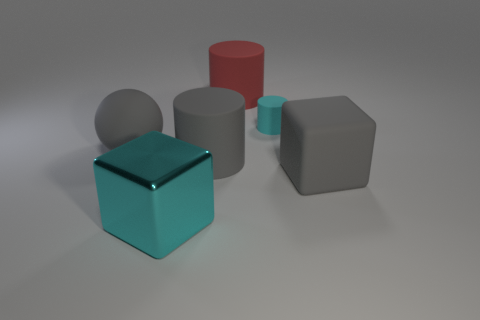Add 1 matte blocks. How many objects exist? 7 Subtract all spheres. How many objects are left? 5 Subtract 0 yellow cubes. How many objects are left? 6 Subtract all big rubber cylinders. Subtract all large gray objects. How many objects are left? 1 Add 3 big cylinders. How many big cylinders are left? 5 Add 1 cyan matte objects. How many cyan matte objects exist? 2 